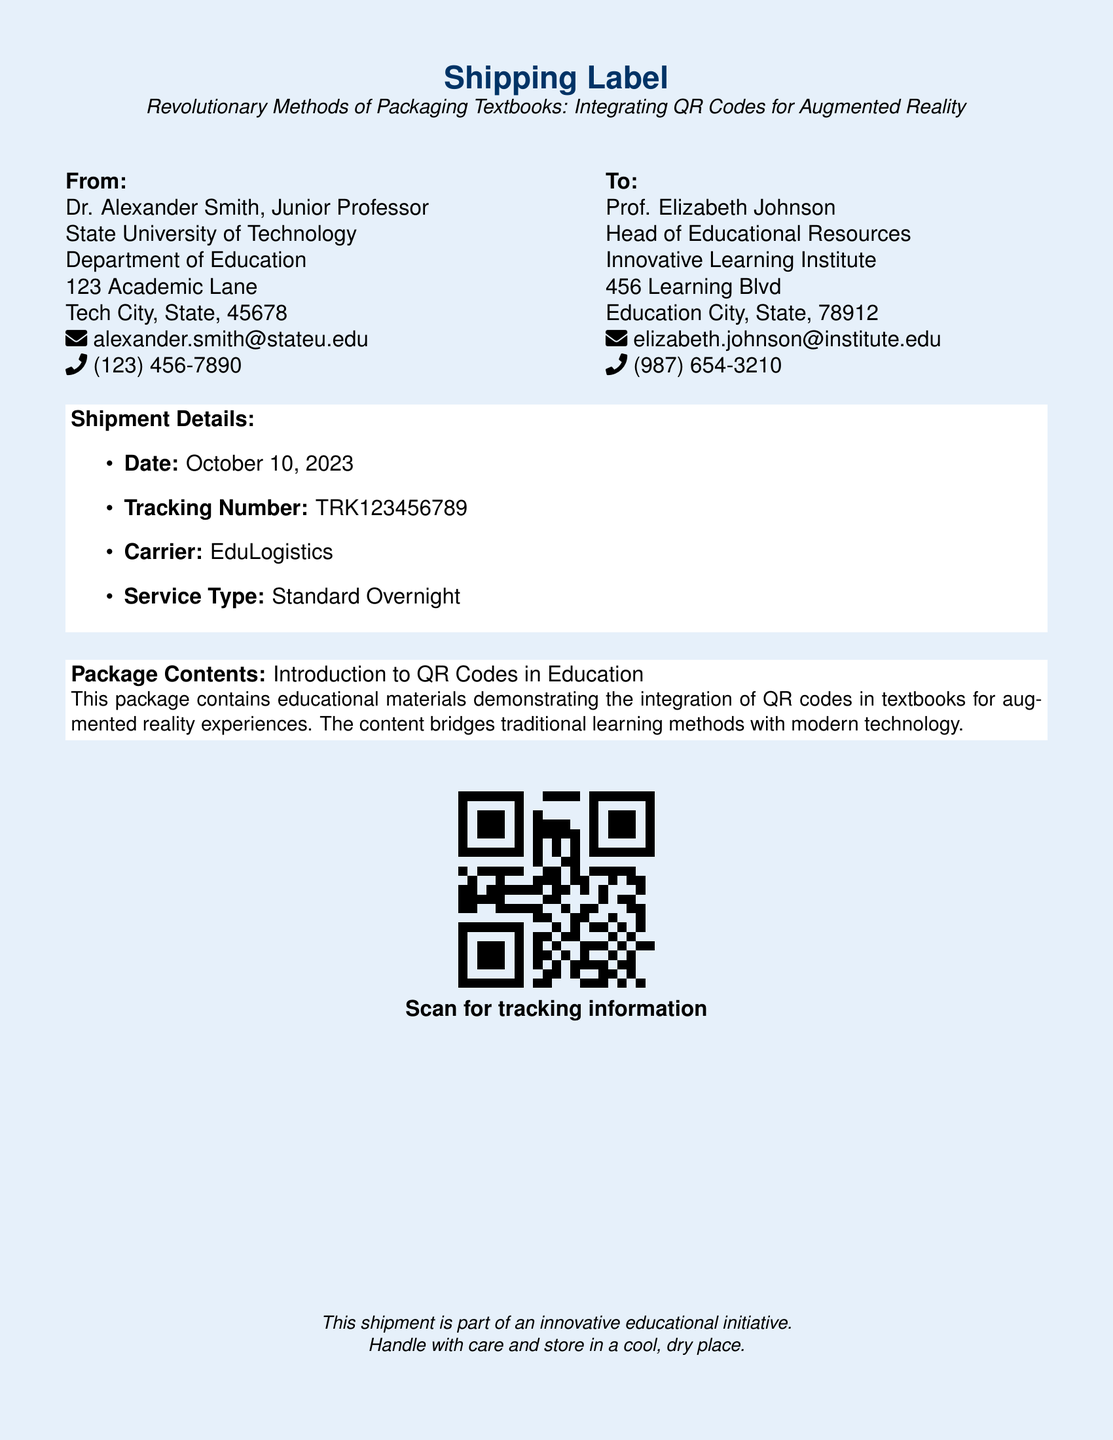What is the name of the sender? The sender is Dr. Alexander Smith, who is a Junior Professor at State University of Technology.
Answer: Dr. Alexander Smith What is the tracking number? The tracking number is specifically listed in the shipment details.
Answer: TRK123456789 What is the date of the shipment? The date is explicitly mentioned under the shipment details.
Answer: October 10, 2023 Who is the recipient of the shipment? The recipient's name and title are provided in the "To" section.
Answer: Prof. Elizabeth Johnson What is the package content? The content of the package is summarized in one sentence.
Answer: Introduction to QR Codes in Education What type of service is being used for shipping? The service type is specified under the shipment details.
Answer: Standard Overnight What is the name of the carrier? The carrier's name is mentioned in the shipment details section.
Answer: EduLogistics What does the QR code provide? The function of the QR code is explained beneath it.
Answer: Tracking information How should the package be handled? A precaution about handling is included in the footer of the label.
Answer: Handle with care 